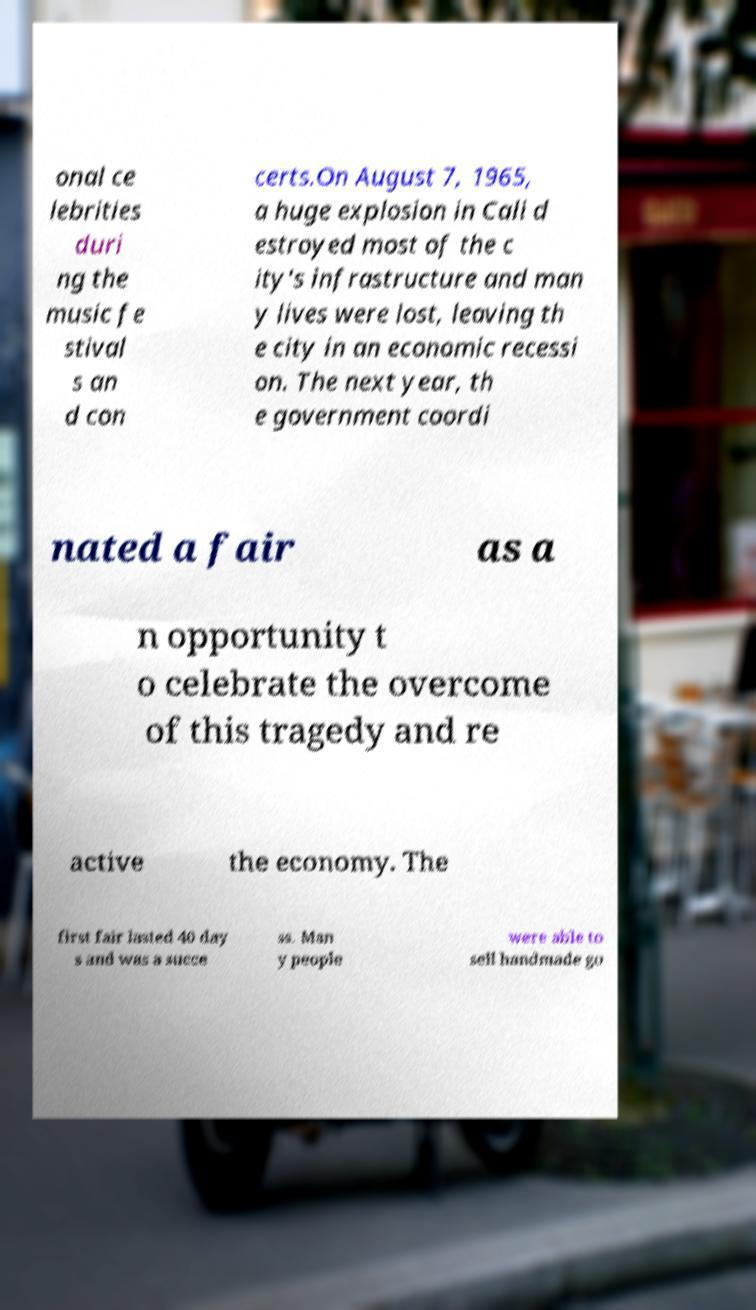There's text embedded in this image that I need extracted. Can you transcribe it verbatim? onal ce lebrities duri ng the music fe stival s an d con certs.On August 7, 1965, a huge explosion in Cali d estroyed most of the c ity's infrastructure and man y lives were lost, leaving th e city in an economic recessi on. The next year, th e government coordi nated a fair as a n opportunity t o celebrate the overcome of this tragedy and re active the economy. The first fair lasted 40 day s and was a succe ss. Man y people were able to sell handmade go 